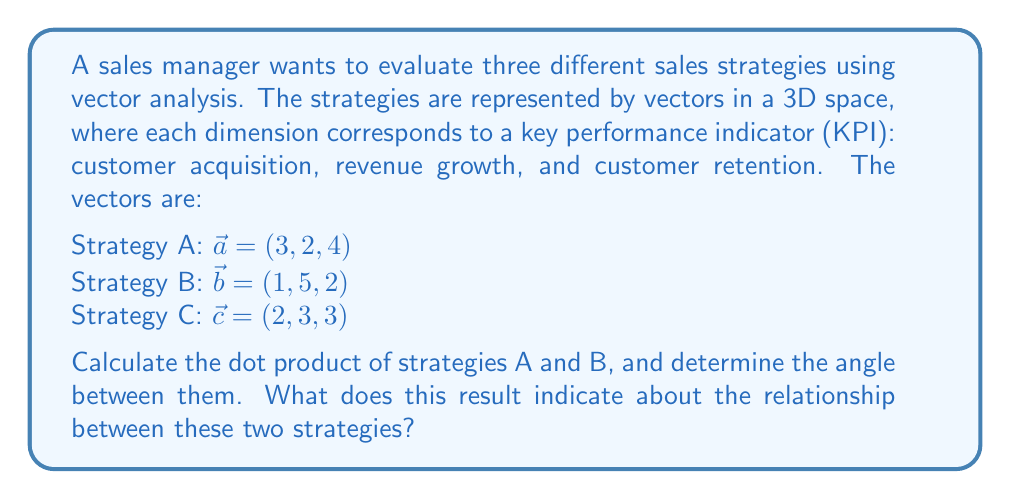Teach me how to tackle this problem. To solve this problem, we'll follow these steps:

1. Calculate the dot product of vectors $\vec{a}$ and $\vec{b}$:
   $$\vec{a} \cdot \vec{b} = (3 \times 1) + (2 \times 5) + (4 \times 2) = 3 + 10 + 8 = 21$$

2. Calculate the magnitudes of vectors $\vec{a}$ and $\vec{b}$:
   $$|\vec{a}| = \sqrt{3^2 + 2^2 + 4^2} = \sqrt{9 + 4 + 16} = \sqrt{29}$$
   $$|\vec{b}| = \sqrt{1^2 + 5^2 + 2^2} = \sqrt{1 + 25 + 4} = \sqrt{30}$$

3. Use the dot product formula to find the cosine of the angle between the vectors:
   $$\cos \theta = \frac{\vec{a} \cdot \vec{b}}{|\vec{a}||\vec{b}|} = \frac{21}{\sqrt{29}\sqrt{30}}$$

4. Calculate the angle $\theta$ using the inverse cosine function:
   $$\theta = \arccos\left(\frac{21}{\sqrt{29}\sqrt{30}}\right) \approx 0.5365 \text{ radians} \approx 30.74°$$

5. Interpret the result:
   The angle between strategies A and B is approximately 30.74°. This relatively small angle indicates that the two strategies are somewhat aligned in their focus on the three KPIs. However, they are not perfectly aligned (which would be 0°), suggesting some differences in their approach to customer acquisition, revenue growth, and customer retention.
Answer: $\theta \approx 30.74°$, indicating partial alignment between strategies A and B. 